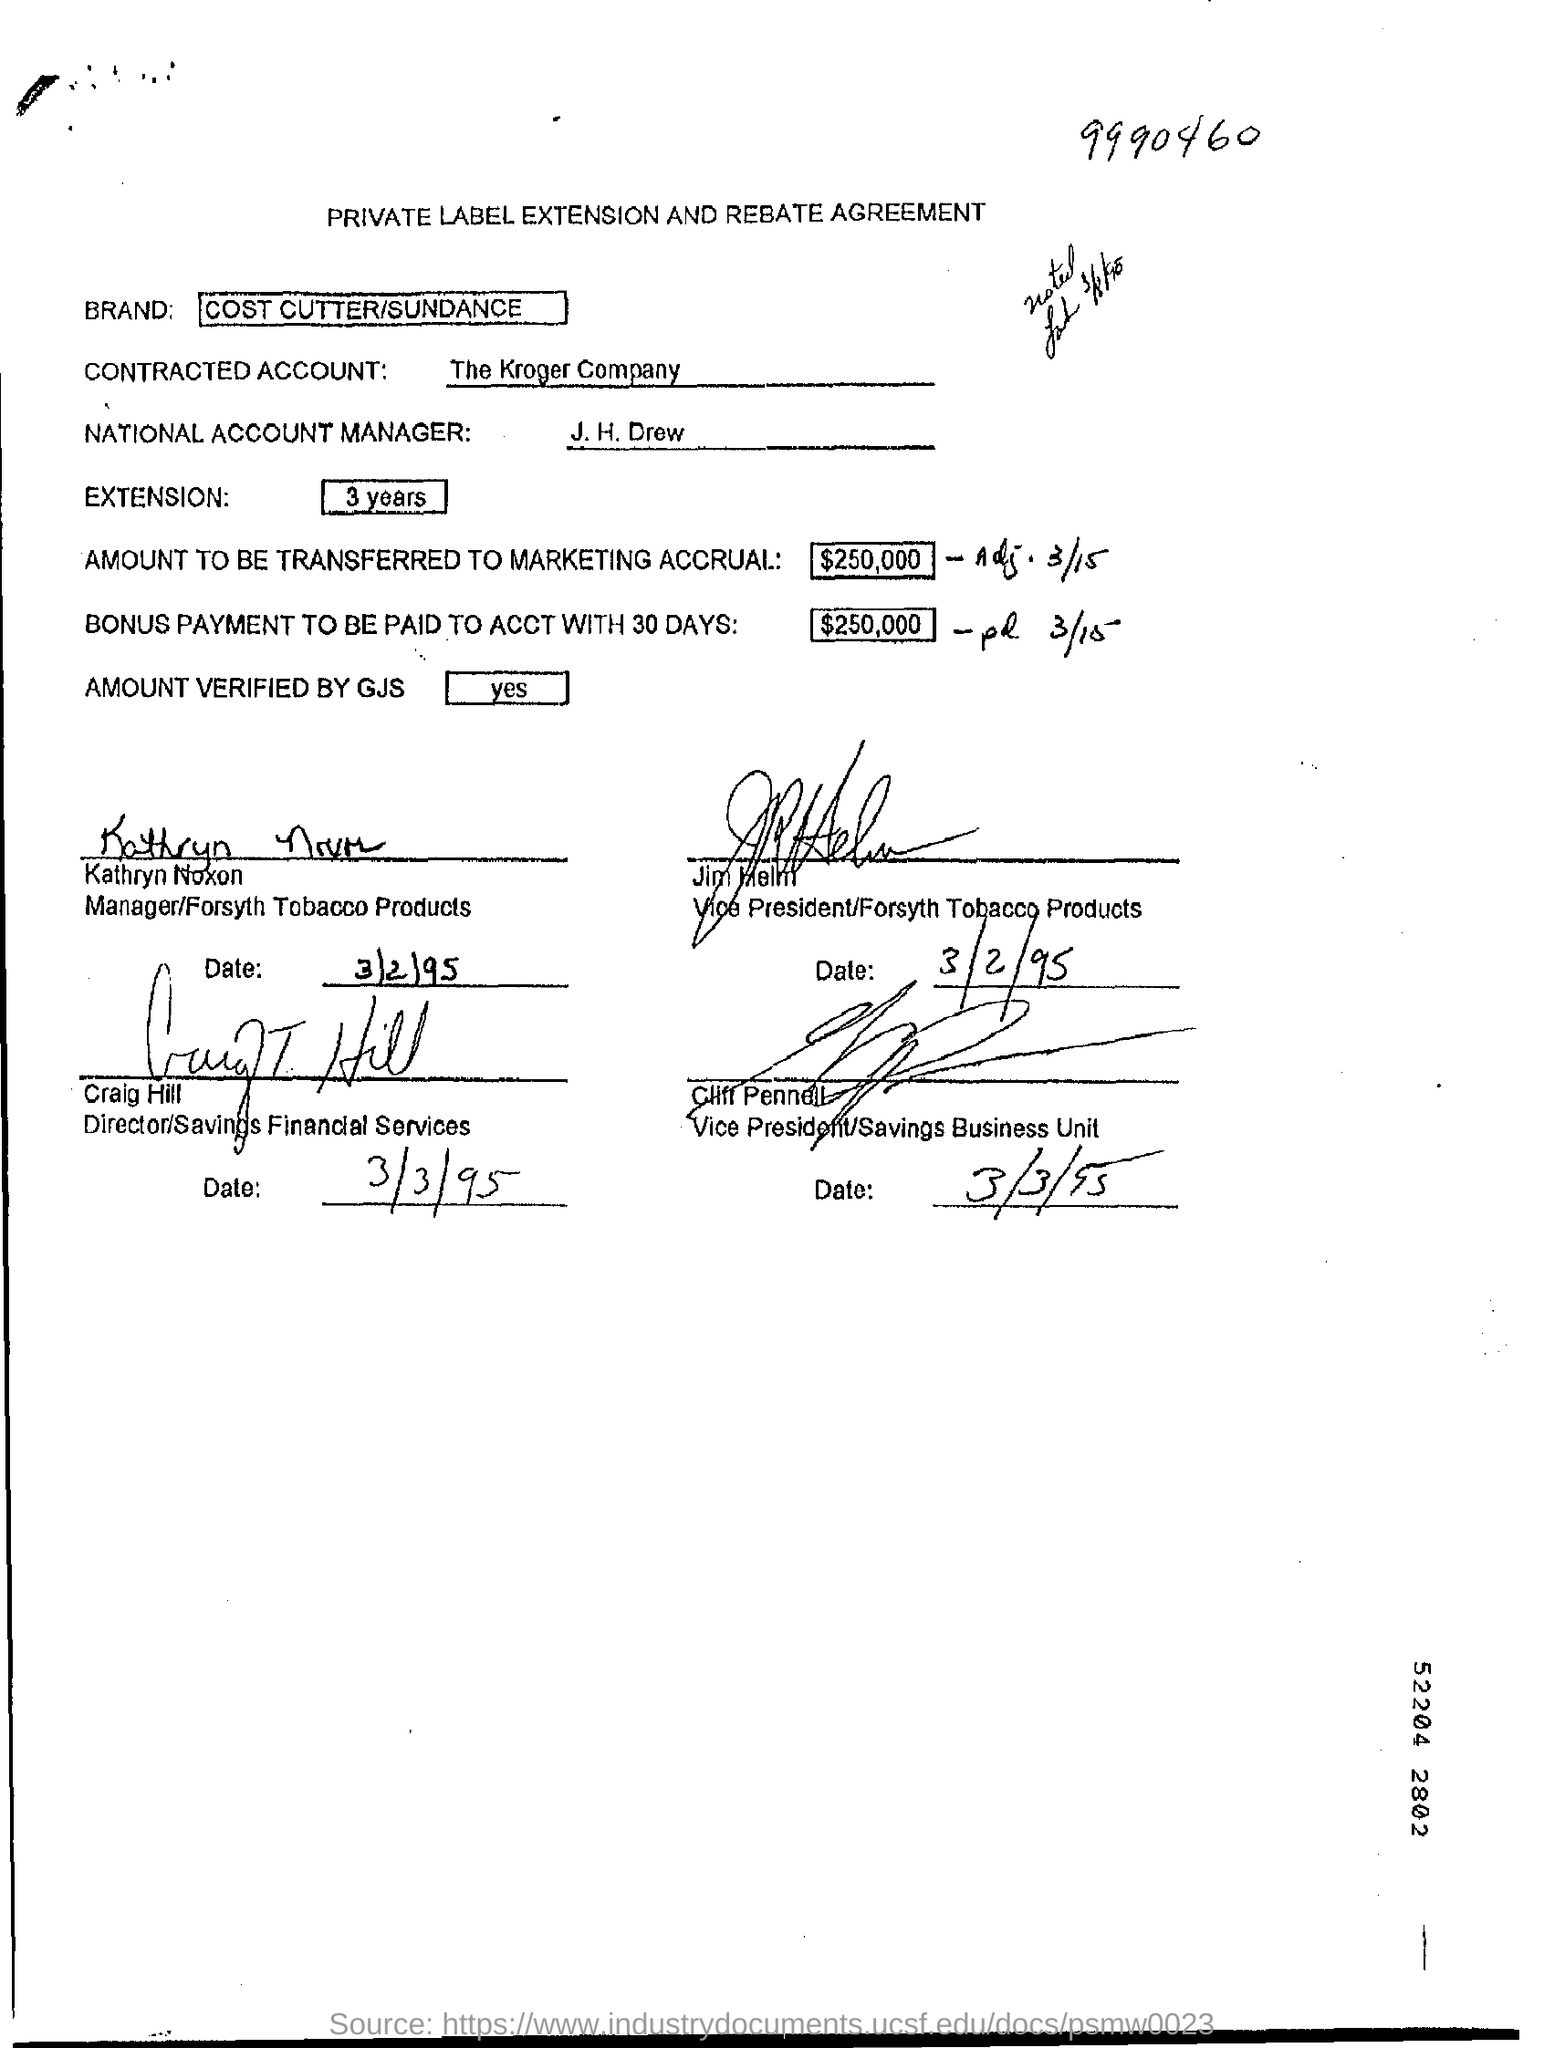List a handful of essential elements in this visual. The brand mentioned in the form is COST CUTTER/SUNDANCE. The heading of the document is 'Private Label Extension and Rebate Agreement.' The Kroger Company has a contracted account. 